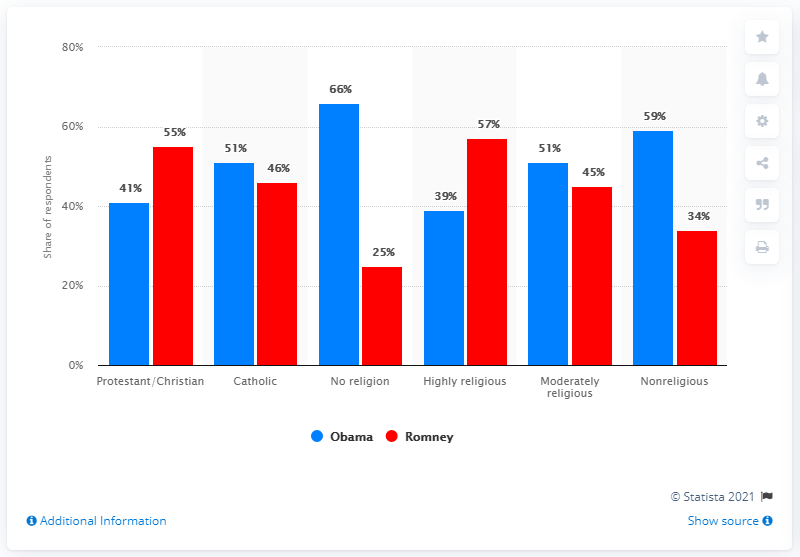Give some essential details in this illustration. I want to find the average of all blue bars that belong to Obama, and then remove the result from my list. In the chart, the data of Romney, one of the leaders, is shown in a red bar. 